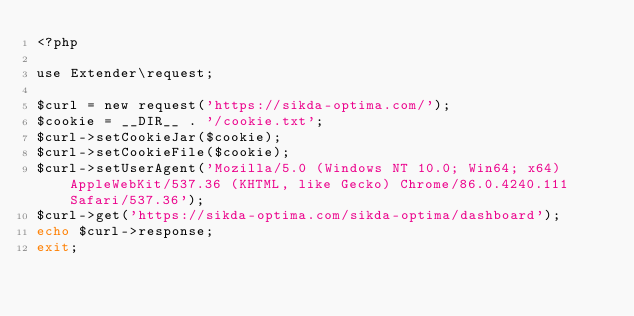Convert code to text. <code><loc_0><loc_0><loc_500><loc_500><_PHP_><?php

use Extender\request;

$curl = new request('https://sikda-optima.com/');
$cookie = __DIR__ . '/cookie.txt';
$curl->setCookieJar($cookie);
$curl->setCookieFile($cookie);
$curl->setUserAgent('Mozilla/5.0 (Windows NT 10.0; Win64; x64) AppleWebKit/537.36 (KHTML, like Gecko) Chrome/86.0.4240.111 Safari/537.36');
$curl->get('https://sikda-optima.com/sikda-optima/dashboard');
echo $curl->response;
exit;
</code> 